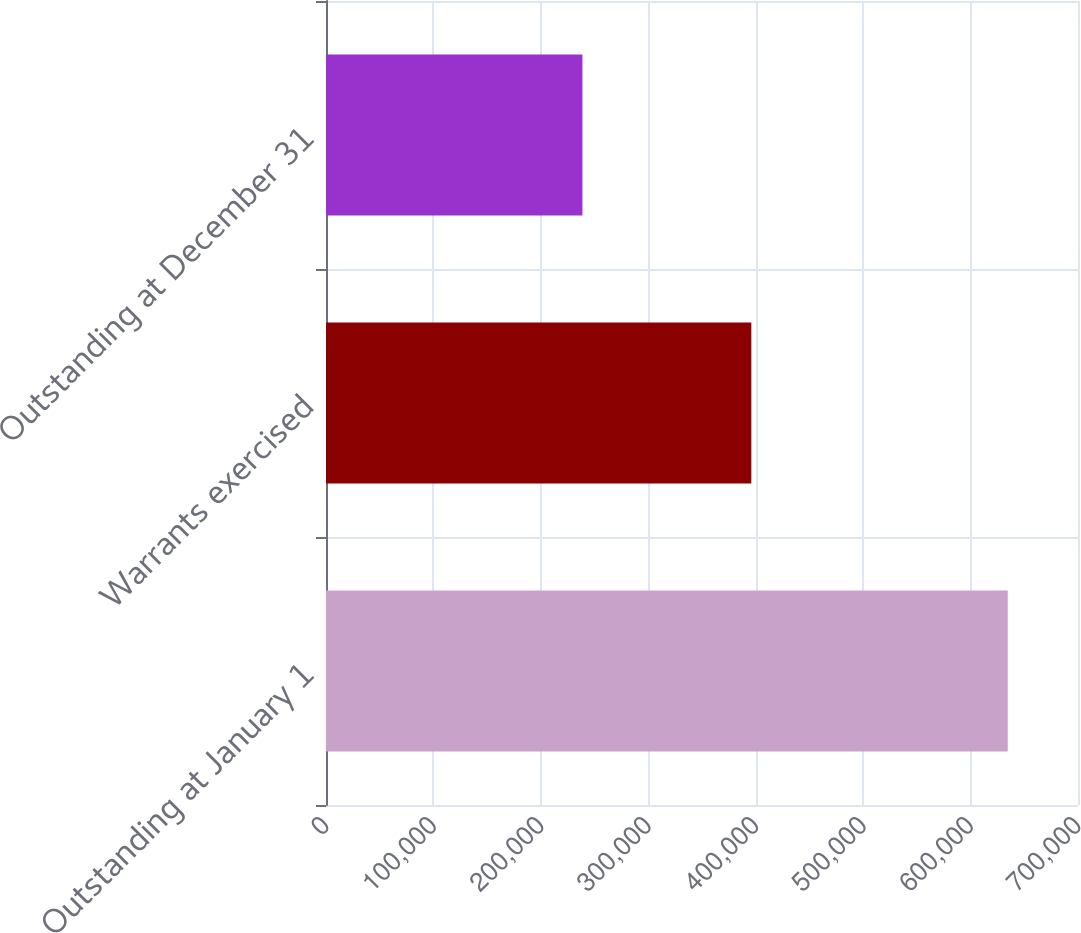<chart> <loc_0><loc_0><loc_500><loc_500><bar_chart><fcel>Outstanding at January 1<fcel>Warrants exercised<fcel>Outstanding at December 31<nl><fcel>634611<fcel>395908<fcel>238703<nl></chart> 